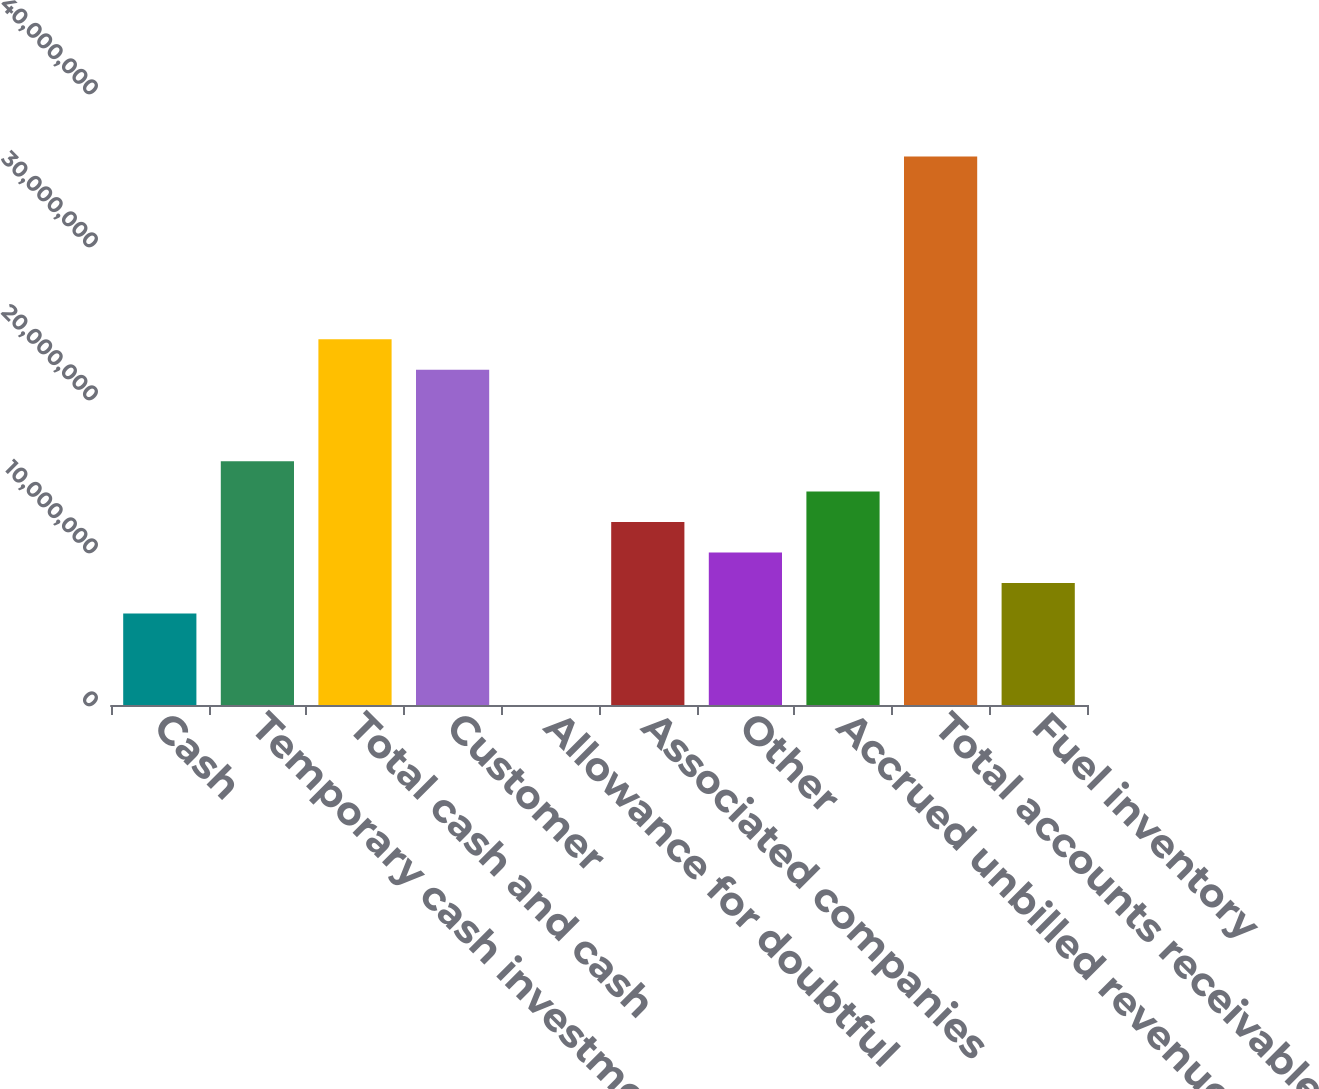Convert chart to OTSL. <chart><loc_0><loc_0><loc_500><loc_500><bar_chart><fcel>Cash<fcel>Temporary cash investments<fcel>Total cash and cash<fcel>Customer<fcel>Allowance for doubtful<fcel>Associated companies<fcel>Other<fcel>Accrued unbilled revenues<fcel>Total accounts receivable<fcel>Fuel inventory<nl><fcel>5.9805e+06<fcel>1.59375e+07<fcel>2.39032e+07<fcel>2.19118e+07<fcel>6277<fcel>1.19547e+07<fcel>9.96332e+06<fcel>1.39461e+07<fcel>3.58516e+07<fcel>7.97191e+06<nl></chart> 